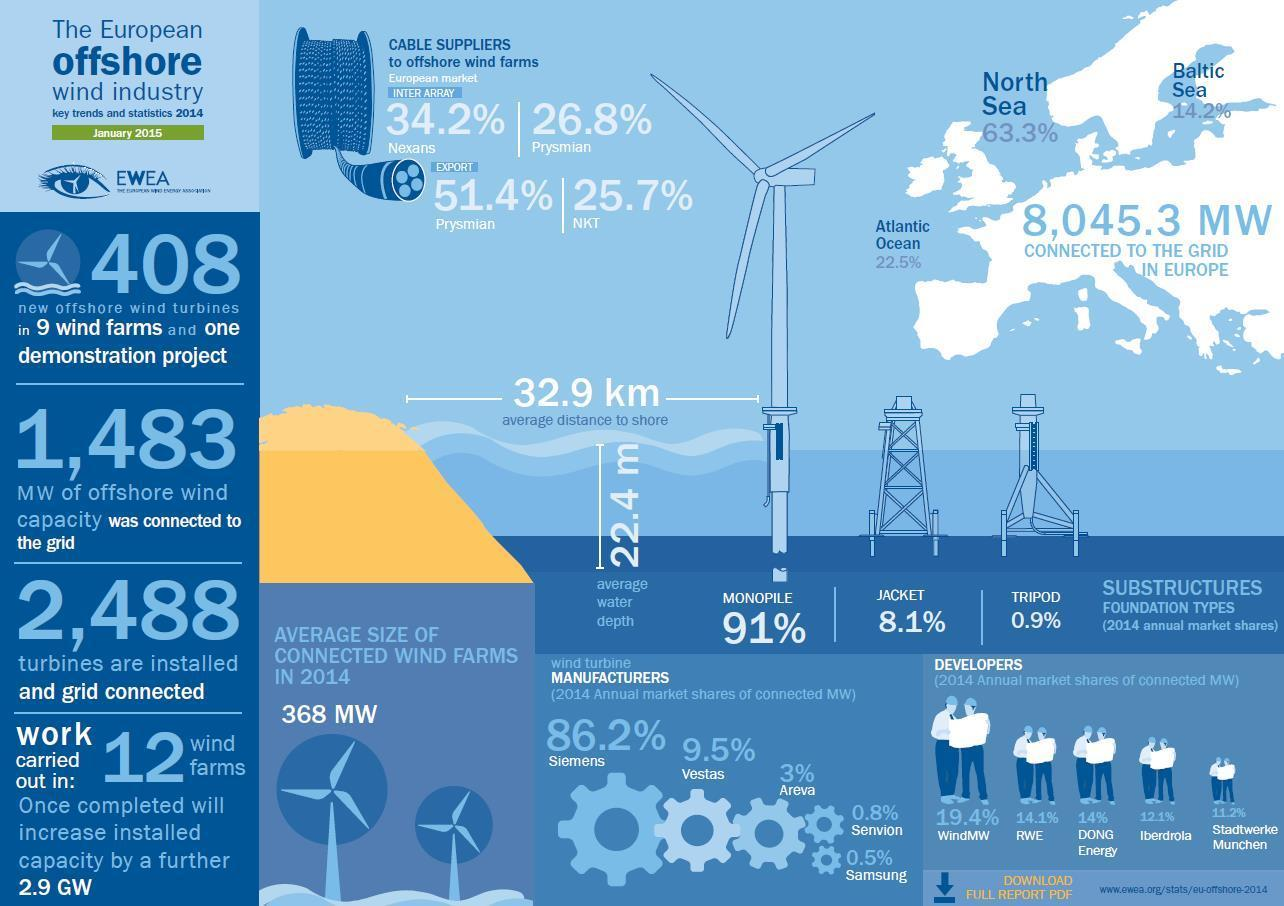What percentage has Tripod as substructure foundation type?
Answer the question with a short phrase. 0.9% What percentage does Samsung contribute as wind turbine manufacturer? 0.5% What percentage has Monopile as substructure foundation type? 91% 